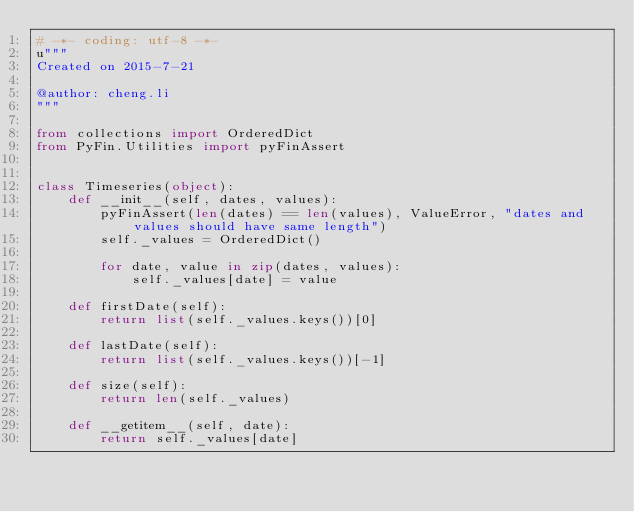<code> <loc_0><loc_0><loc_500><loc_500><_Python_># -*- coding: utf-8 -*-
u"""
Created on 2015-7-21

@author: cheng.li
"""

from collections import OrderedDict
from PyFin.Utilities import pyFinAssert


class Timeseries(object):
    def __init__(self, dates, values):
        pyFinAssert(len(dates) == len(values), ValueError, "dates and values should have same length")
        self._values = OrderedDict()

        for date, value in zip(dates, values):
            self._values[date] = value

    def firstDate(self):
        return list(self._values.keys())[0]

    def lastDate(self):
        return list(self._values.keys())[-1]

    def size(self):
        return len(self._values)

    def __getitem__(self, date):
        return self._values[date]
</code> 